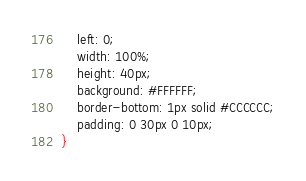Convert code to text. <code><loc_0><loc_0><loc_500><loc_500><_CSS_>    left: 0;
    width: 100%;
    height: 40px;
    background: #FFFFFF;
    border-bottom: 1px solid #CCCCCC;
    padding: 0 30px 0 10px;
}
</code> 